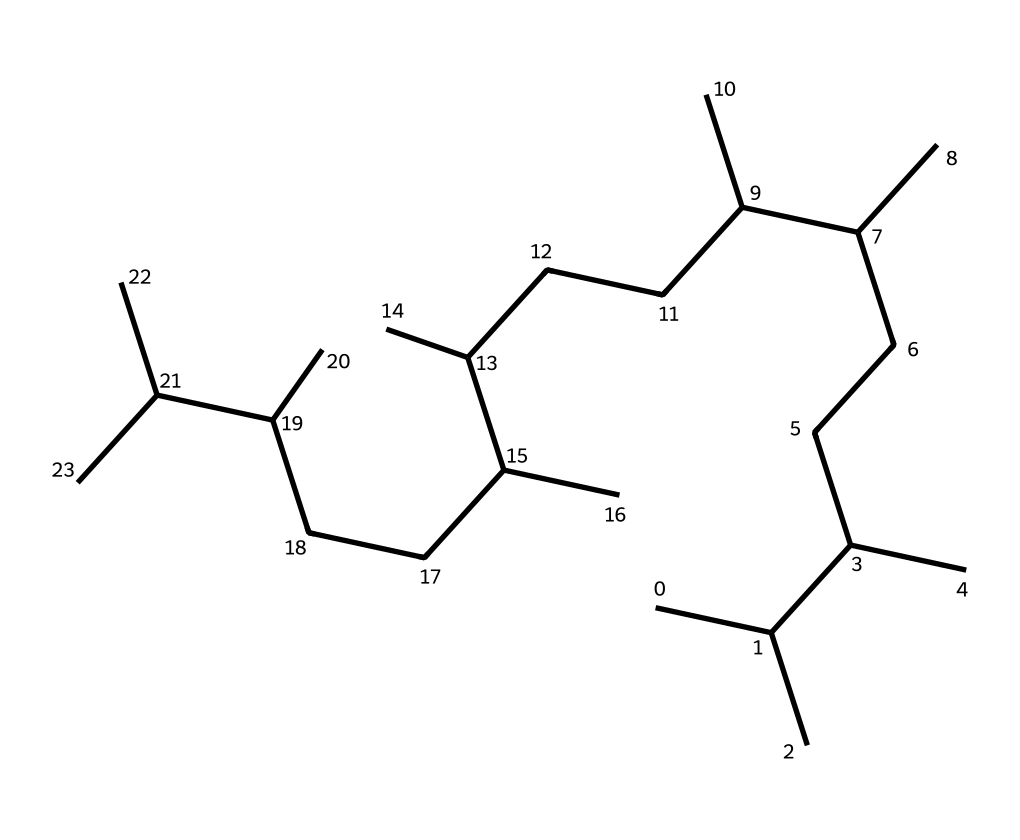What is the molecular formula derived from the SMILES? The SMILES indicates a long hydrocarbon chain with repeating units. To determine the molecular formula, count the number of carbon (C) and hydrogen (H) atoms in the structure. There are 30 carbon atoms and 62 hydrogen atoms, leading to a molecular formula of C30H62.
Answer: C30H62 How many carbon atoms are present in this chemical? By analyzing the SMILES representation, you can count the number of 'C' symbols, which represent carbon atoms. There are 30 instances of 'C', indicating there are 30 carbon atoms.
Answer: 30 Is this chemical a saturated or unsaturated hydrocarbon? The SMILES structure does not indicate any double or triple bonds (which would signify unsaturation). The presence of only single bonds confirms that this structure is a saturated hydrocarbon.
Answer: saturated What is the typical use of polyalphaolefin oils? Polyalphaolefins are commonly used as synthetic lubricants in industrial machinery due to their stability, low volatility, and thermal resistance. This characteristic makes them ideal for high-performance lubrication applications.
Answer: lubrication What type of industrial applications would benefit from using this compound? Given its properties and structure, polyalphaolefins are especially suitable for high-load and high-temperature applications, such as in machinery lubrication, automotive oils, and other industrial lubrication systems.
Answer: industrial lubrication What is the significance of the long carbon chain in this lubricant? A long carbon chain contributes to the viscosity and lubrication properties of the oil. It enhances film strength and lowers volatility, making it effective at maintaining performance under extreme conditions.
Answer: viscosity What characteristic does this compound impart to the lubricant's performance? The long alkyl chains in the structure offer low pour points and high thermal stability, which improves the lubricant's performance, particularly in extreme temperatures and under stress.
Answer: thermal stability 